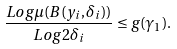<formula> <loc_0><loc_0><loc_500><loc_500>\frac { L o g \mu ( B ( y _ { i } , \delta _ { i } ) ) } { L o g 2 \delta _ { i } } \leq g ( \gamma _ { 1 } ) .</formula> 